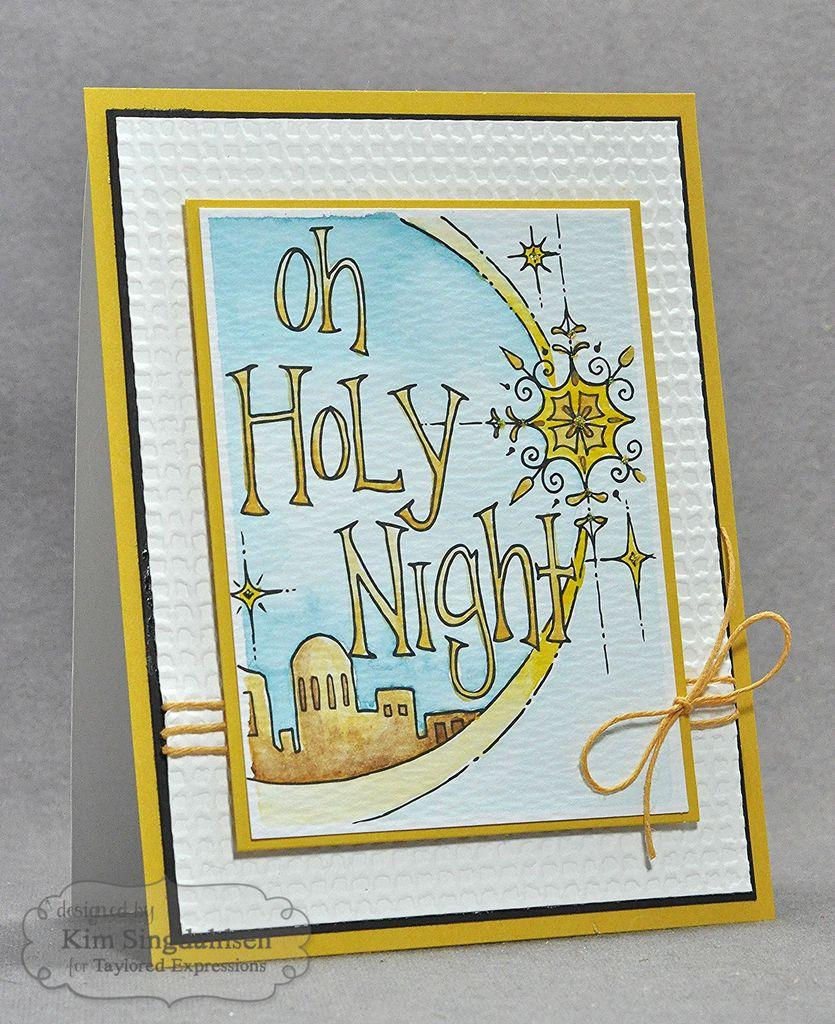What is the primary object in the image? There is a card in the image. Is there anything connected to the card? Yes, the card has a thread attached to it. What can be seen on the card? There is a drawing on the card. Are there any additional features in the image? Yes, there is a watermark on the image. Can you see a yak grazing near the river during the summer in the image? There is no yak, river, or any reference to summer in the image; it only features a card with a thread, a drawing, and a watermark. 